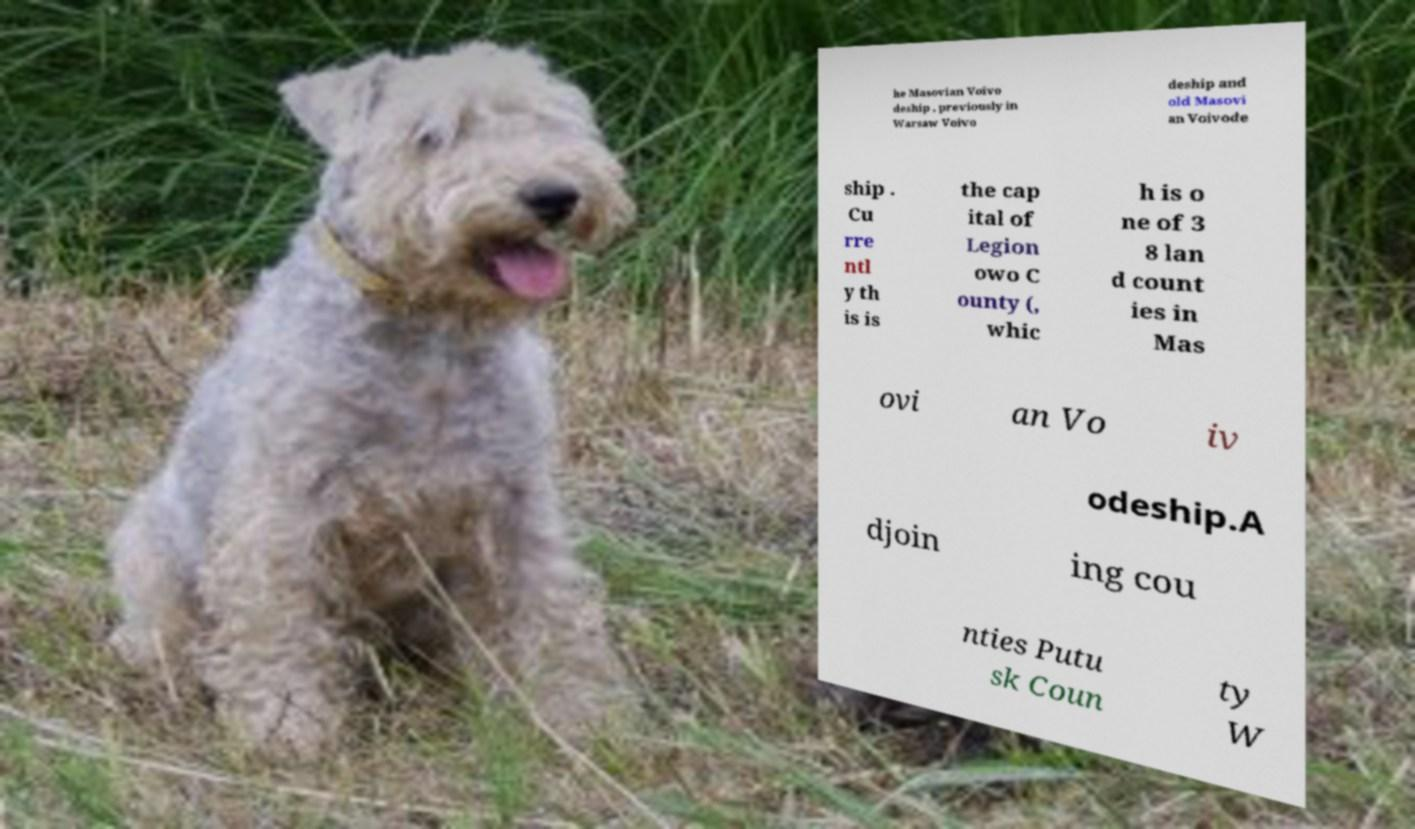For documentation purposes, I need the text within this image transcribed. Could you provide that? he Masovian Voivo deship , previously in Warsaw Voivo deship and old Masovi an Voivode ship . Cu rre ntl y th is is the cap ital of Legion owo C ounty (, whic h is o ne of 3 8 lan d count ies in Mas ovi an Vo iv odeship.A djoin ing cou nties Putu sk Coun ty W 